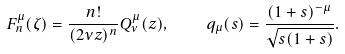Convert formula to latex. <formula><loc_0><loc_0><loc_500><loc_500>F _ { n } ^ { \mu } ( \zeta ) = \frac { n ! } { ( 2 \nu z ) ^ { n } } Q _ { \nu } ^ { \mu } ( z ) , \quad q _ { \mu } ( s ) = \frac { ( 1 + s ) ^ { - \mu } } { \sqrt { s ( 1 + s ) } } .</formula> 